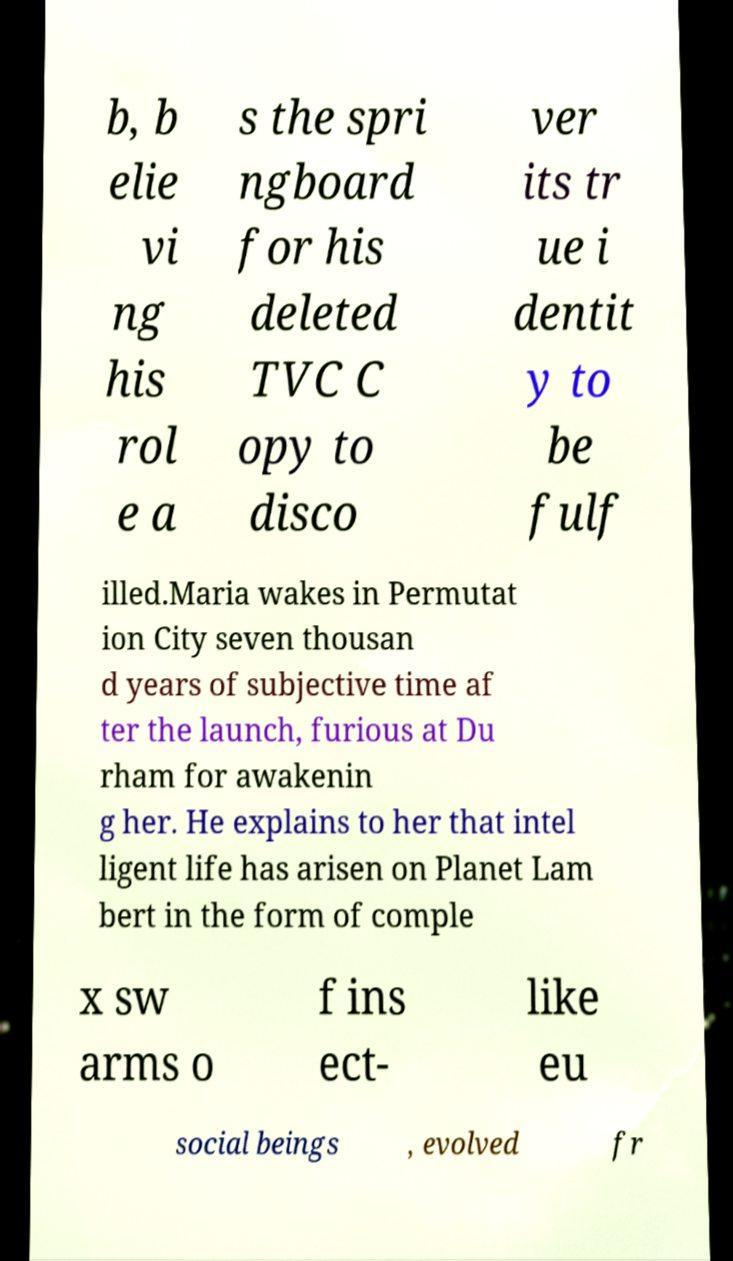Could you assist in decoding the text presented in this image and type it out clearly? b, b elie vi ng his rol e a s the spri ngboard for his deleted TVC C opy to disco ver its tr ue i dentit y to be fulf illed.Maria wakes in Permutat ion City seven thousan d years of subjective time af ter the launch, furious at Du rham for awakenin g her. He explains to her that intel ligent life has arisen on Planet Lam bert in the form of comple x sw arms o f ins ect- like eu social beings , evolved fr 